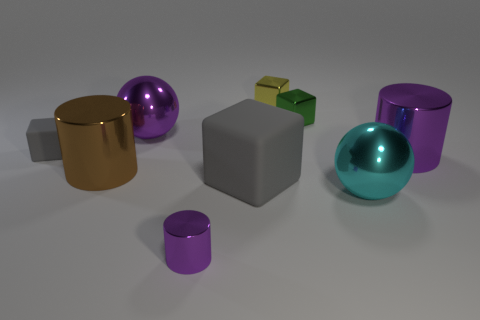Subtract all purple shiny cylinders. How many cylinders are left? 1 Add 1 yellow objects. How many objects exist? 10 Subtract all purple cylinders. How many cylinders are left? 1 Subtract 1 spheres. How many spheres are left? 1 Add 6 tiny purple metallic things. How many tiny purple metallic things exist? 7 Subtract 0 blue cubes. How many objects are left? 9 Subtract all cylinders. How many objects are left? 6 Subtract all yellow cubes. Subtract all blue cylinders. How many cubes are left? 3 Subtract all brown spheres. How many brown cylinders are left? 1 Subtract all cubes. Subtract all brown objects. How many objects are left? 4 